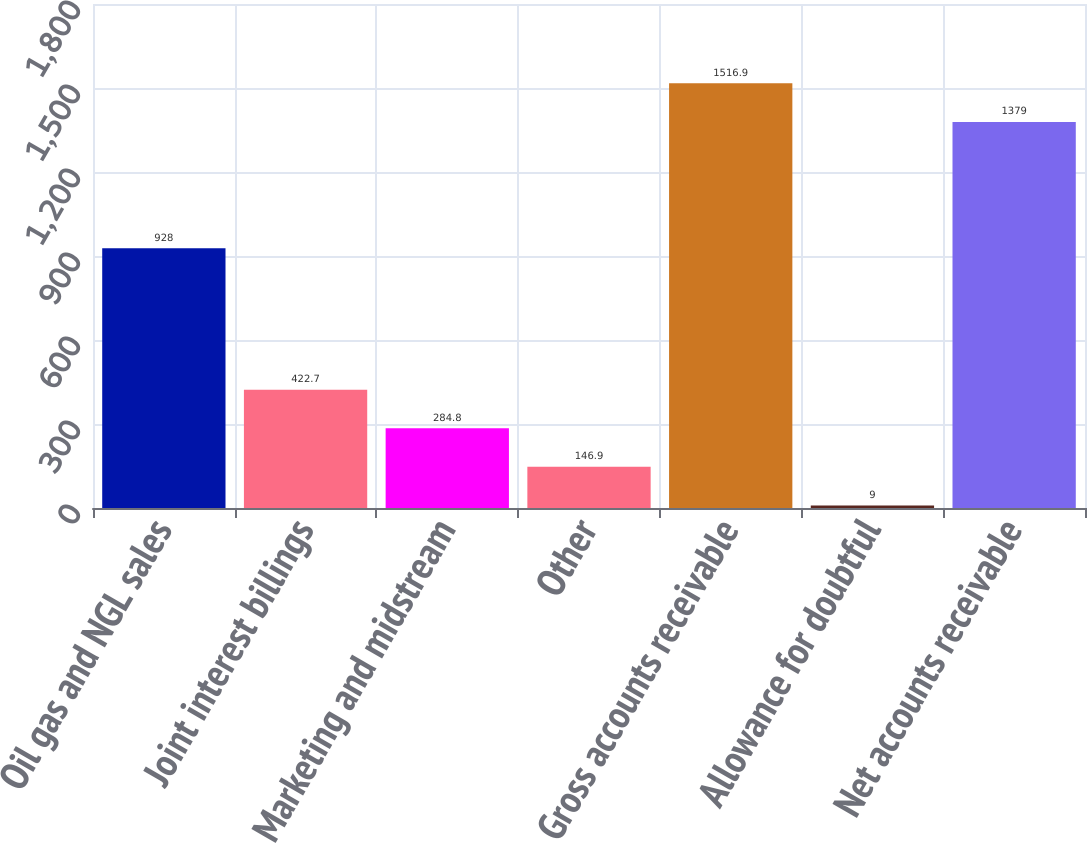Convert chart. <chart><loc_0><loc_0><loc_500><loc_500><bar_chart><fcel>Oil gas and NGL sales<fcel>Joint interest billings<fcel>Marketing and midstream<fcel>Other<fcel>Gross accounts receivable<fcel>Allowance for doubtful<fcel>Net accounts receivable<nl><fcel>928<fcel>422.7<fcel>284.8<fcel>146.9<fcel>1516.9<fcel>9<fcel>1379<nl></chart> 